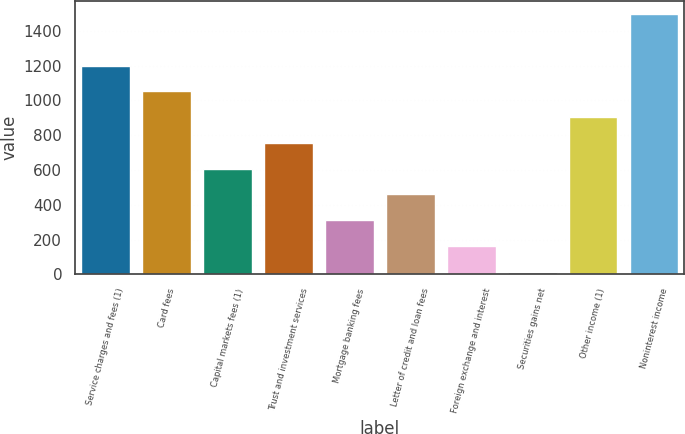Convert chart. <chart><loc_0><loc_0><loc_500><loc_500><bar_chart><fcel>Service charges and fees (1)<fcel>Card fees<fcel>Capital markets fees (1)<fcel>Trust and investment services<fcel>Mortgage banking fees<fcel>Letter of credit and loan fees<fcel>Foreign exchange and interest<fcel>Securities gains net<fcel>Other income (1)<fcel>Noninterest income<nl><fcel>1200.8<fcel>1052.7<fcel>608.4<fcel>756.5<fcel>312.2<fcel>460.3<fcel>164.1<fcel>16<fcel>904.6<fcel>1497<nl></chart> 